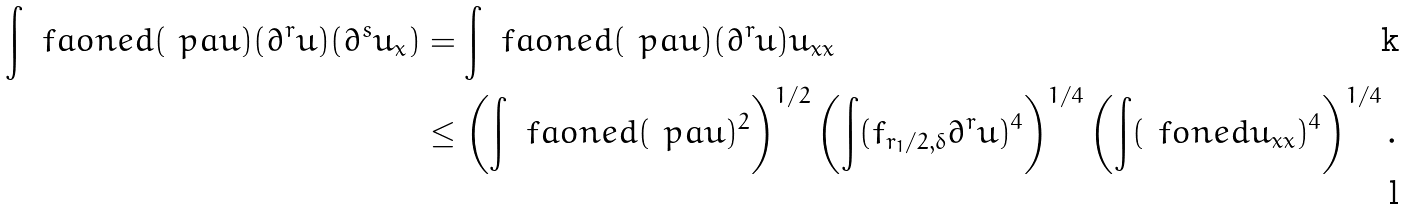<formula> <loc_0><loc_0><loc_500><loc_500>\int \ f a o n e d ( \ p a u ) ( \partial ^ { r } u ) ( \partial ^ { s } u _ { x } ) & = \int \ f a o n e d ( \ p a u ) ( \partial ^ { r } u ) u _ { x x } \\ & \leq \left ( \int \ f a o n e d ( \ p a u ) ^ { 2 } \right ) ^ { 1 / 2 } \left ( \int ( f _ { r _ { 1 } / 2 , \delta } \partial ^ { r } u ) ^ { 4 } \right ) ^ { 1 / 4 } \left ( \int ( \ f o n e d u _ { x x } ) ^ { 4 } \right ) ^ { 1 / 4 } .</formula> 